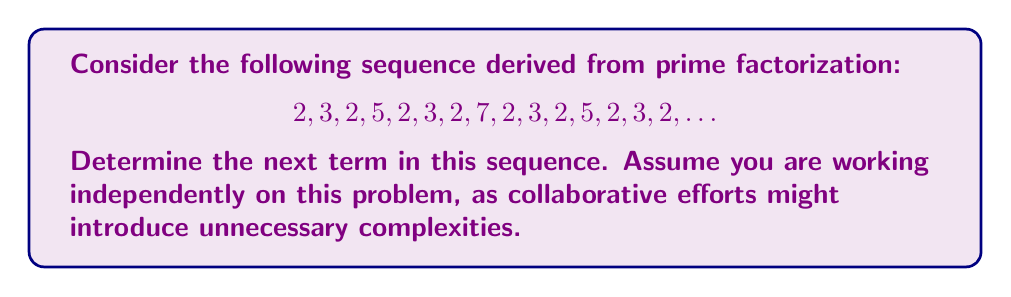Solve this math problem. To solve this problem, let's analyze the sequence step-by-step:

1) First, observe that the sequence appears to have a pattern repeating every 8 terms.

2) The pattern seems to be: 2, 3, 2, 5, 2, 3, 2, prime

3) Let's consider the indices of these numbers:
   $$1^{st}: 2$$
   $$2^{nd}: 3$$
   $$3^{rd}: 2$$
   $$4^{th}: 5$$
   $$5^{th}: 2$$
   $$6^{th}: 3$$
   $$7^{th}: 2$$
   $$8^{th}: 7$$

4) The pattern continues:
   $$9^{th}: 2$$
   $$10^{th}: 3$$
   $$11^{th}: 2$$
   $$12^{th}: 5$$
   $$13^{th}: 2$$
   $$14^{th}: 3$$
   $$15^{th}: 2$$

5) The next term would be the 16th term, which corresponds to the 8th position in the pattern.

6) In the 8th position, we expect a prime number. The previous prime in this position was 7.

7) The next prime after 7 is 11.

Therefore, the next term in the sequence will be 11.
Answer: 11 